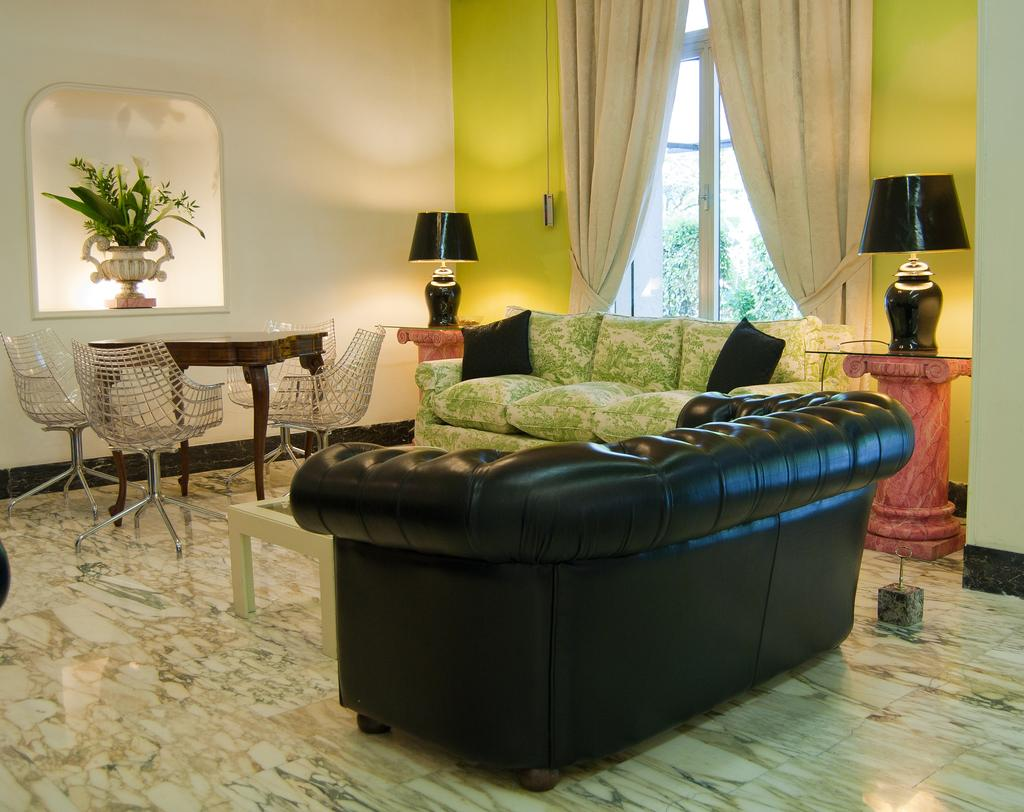How many sofas are in the living room? There are two sofas in the living room. What type of furniture is present for lighting purposes? There are two lamps in the living room. What is the primary piece of furniture for placing items? There is a table in the living room. How many chairs are around the table in the living room? There are four chairs around the table in the living room. What type of texture can be seen on the pigs in the living room? There are no pigs present in the living room; the image only features furniture. 